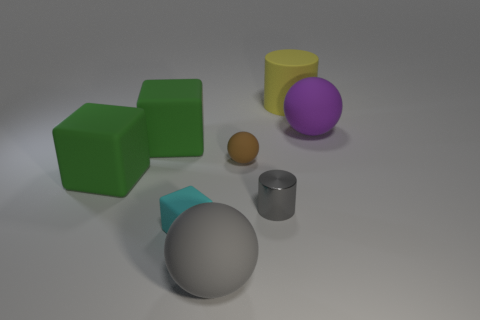Add 1 big green metal balls. How many objects exist? 9 Subtract all big green matte blocks. How many blocks are left? 1 Subtract all red spheres. How many green blocks are left? 2 Subtract all green blocks. How many blocks are left? 1 Subtract all blue cylinders. Subtract all purple balls. How many cylinders are left? 2 Add 4 brown shiny balls. How many brown shiny balls exist? 4 Subtract 0 blue spheres. How many objects are left? 8 Subtract all blocks. How many objects are left? 5 Subtract 1 spheres. How many spheres are left? 2 Subtract all big gray rubber cylinders. Subtract all tiny gray cylinders. How many objects are left? 7 